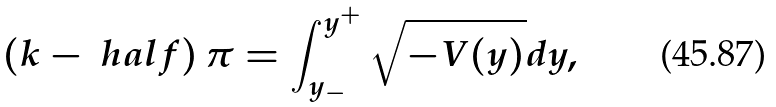<formula> <loc_0><loc_0><loc_500><loc_500>\left ( k - \ h a l f \right ) \pi = \int _ { y _ { - } } ^ { y ^ { + } } \sqrt { - V ( y ) } d y ,</formula> 